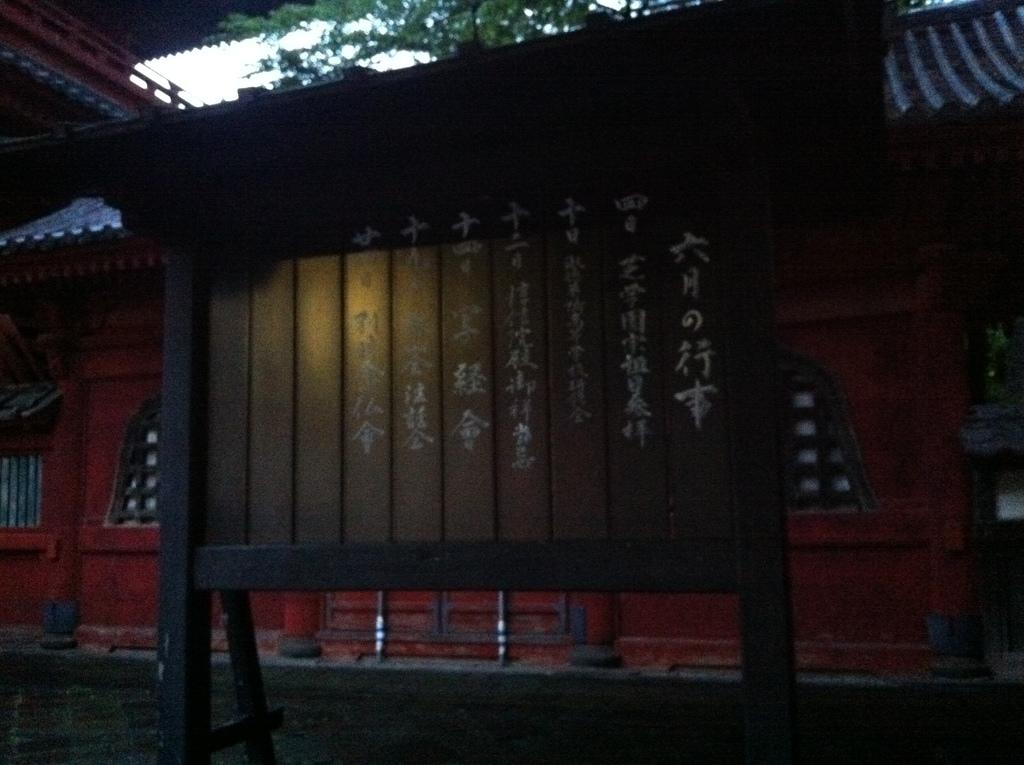What is written on in the image? There are letters written on a wooden board in the image. What can be seen in the background of the image? There is a building and a tree in the background of the image. What is visible above the tree and building in the image? The sky is visible in the background of the image. What type of calculator is being used by the sister in the image? There is no calculator or sister present in the image. Is the crook trying to steal the wooden board in the image? There is no crook or indication of theft in the image; it simply shows a wooden board with letters on it. 